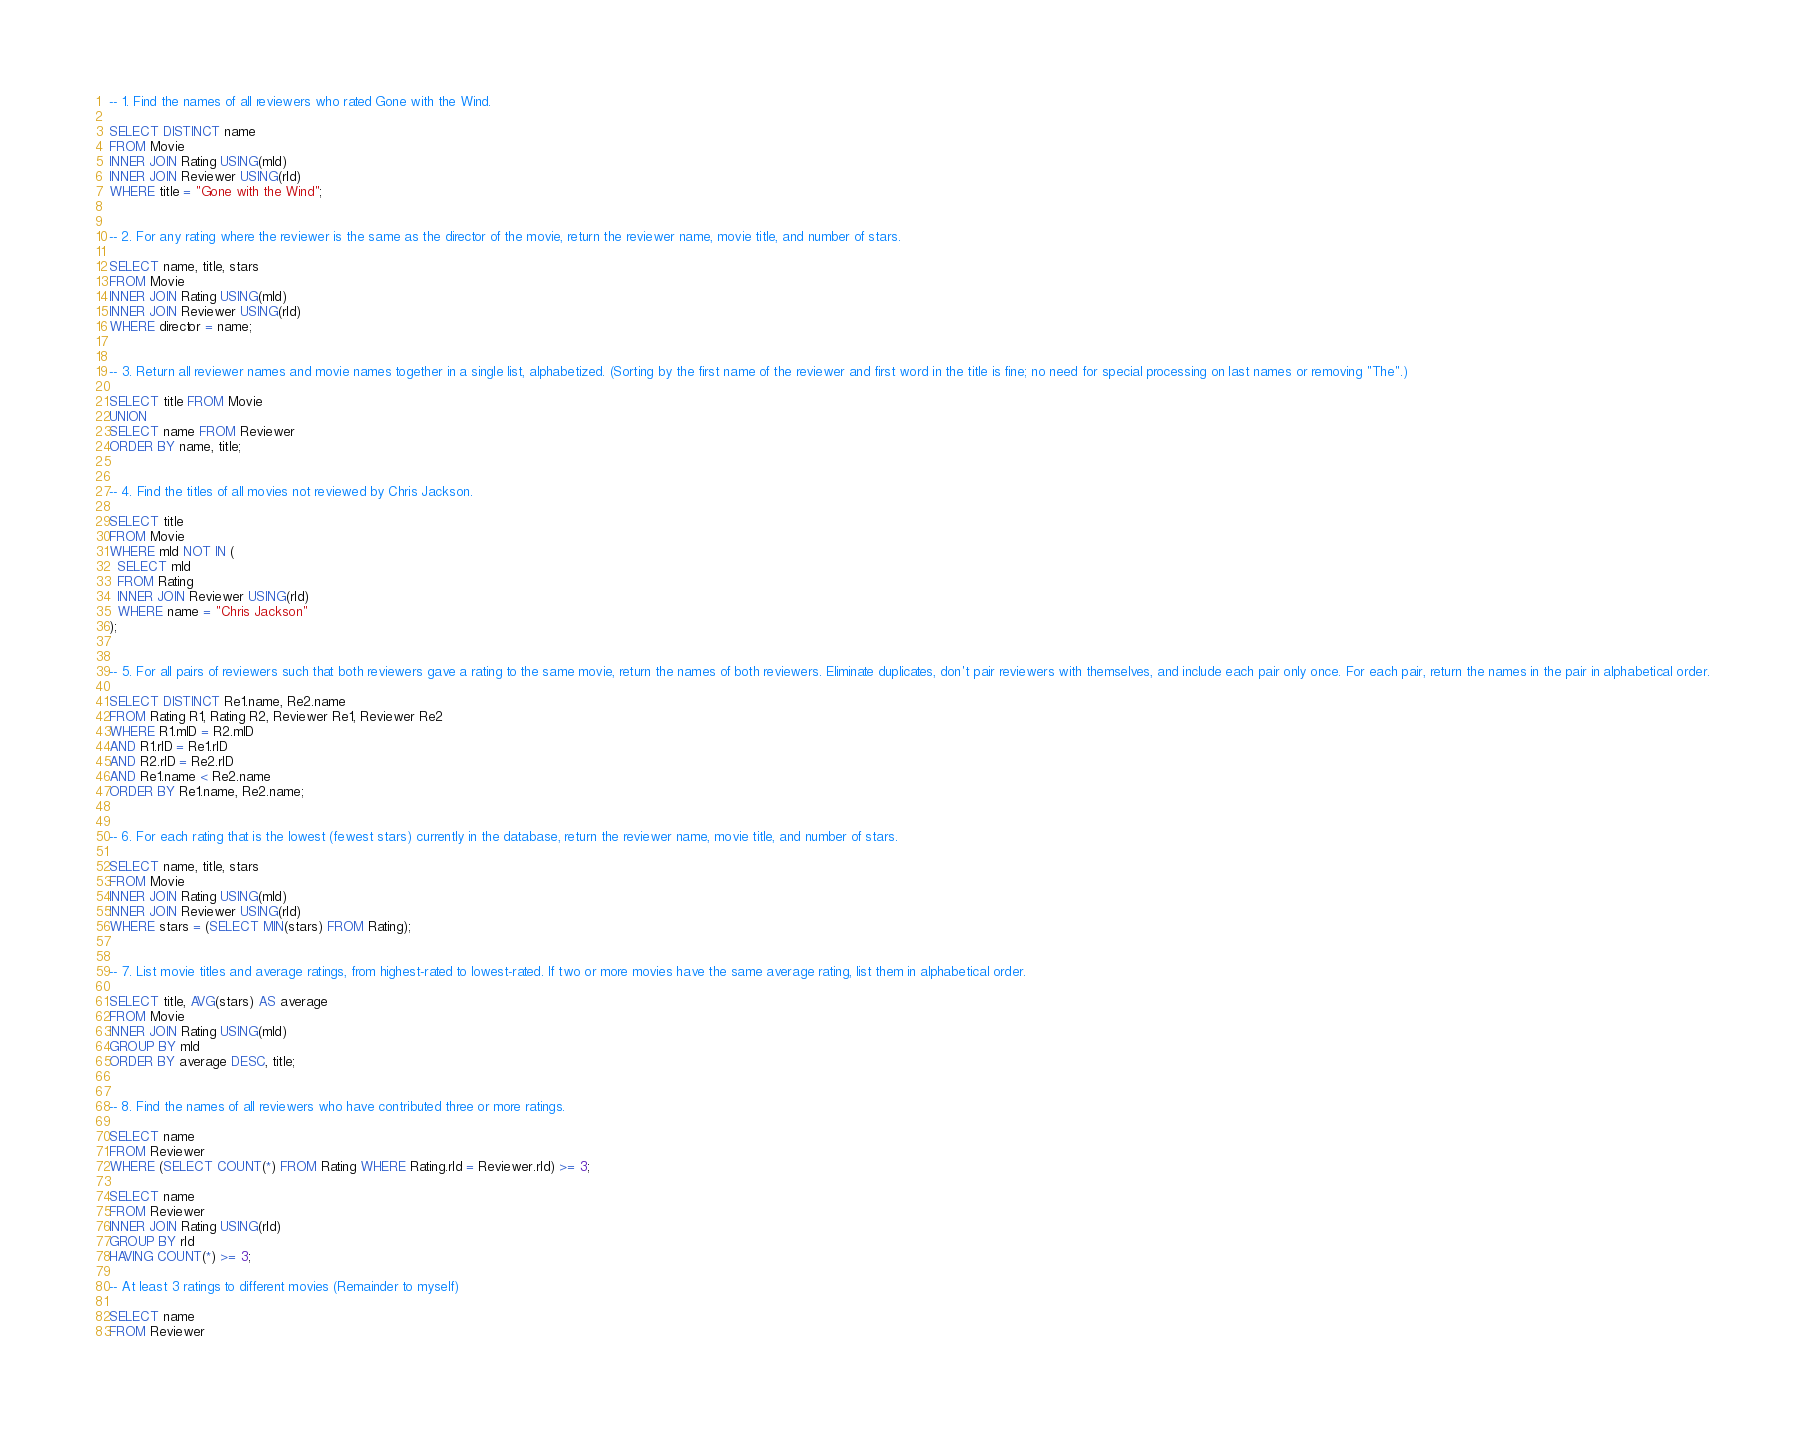Convert code to text. <code><loc_0><loc_0><loc_500><loc_500><_SQL_>-- 1. Find the names of all reviewers who rated Gone with the Wind. 

SELECT DISTINCT name
FROM Movie
INNER JOIN Rating USING(mId)
INNER JOIN Reviewer USING(rId)
WHERE title = "Gone with the Wind";


-- 2. For any rating where the reviewer is the same as the director of the movie, return the reviewer name, movie title, and number of stars. 

SELECT name, title, stars
FROM Movie
INNER JOIN Rating USING(mId)
INNER JOIN Reviewer USING(rId)
WHERE director = name;


-- 3. Return all reviewer names and movie names together in a single list, alphabetized. (Sorting by the first name of the reviewer and first word in the title is fine; no need for special processing on last names or removing "The".) 

SELECT title FROM Movie
UNION
SELECT name FROM Reviewer
ORDER BY name, title;


-- 4. Find the titles of all movies not reviewed by Chris Jackson. 

SELECT title
FROM Movie
WHERE mId NOT IN (
  SELECT mId
  FROM Rating
  INNER JOIN Reviewer USING(rId)
  WHERE name = "Chris Jackson"
);


-- 5. For all pairs of reviewers such that both reviewers gave a rating to the same movie, return the names of both reviewers. Eliminate duplicates, don't pair reviewers with themselves, and include each pair only once. For each pair, return the names in the pair in alphabetical order.

SELECT DISTINCT Re1.name, Re2.name
FROM Rating R1, Rating R2, Reviewer Re1, Reviewer Re2
WHERE R1.mID = R2.mID
AND R1.rID = Re1.rID
AND R2.rID = Re2.rID
AND Re1.name < Re2.name
ORDER BY Re1.name, Re2.name;


-- 6. For each rating that is the lowest (fewest stars) currently in the database, return the reviewer name, movie title, and number of stars.

SELECT name, title, stars
FROM Movie
INNER JOIN Rating USING(mId)
INNER JOIN Reviewer USING(rId)
WHERE stars = (SELECT MIN(stars) FROM Rating);


-- 7. List movie titles and average ratings, from highest-rated to lowest-rated. If two or more movies have the same average rating, list them in alphabetical order. 

SELECT title, AVG(stars) AS average
FROM Movie
INNER JOIN Rating USING(mId)
GROUP BY mId
ORDER BY average DESC, title;


-- 8. Find the names of all reviewers who have contributed three or more ratings.

SELECT name
FROM Reviewer
WHERE (SELECT COUNT(*) FROM Rating WHERE Rating.rId = Reviewer.rId) >= 3;

SELECT name
FROM Reviewer
INNER JOIN Rating USING(rId)
GROUP BY rId
HAVING COUNT(*) >= 3;

-- At least 3 ratings to different movies (Remainder to myself)

SELECT name
FROM Reviewer</code> 